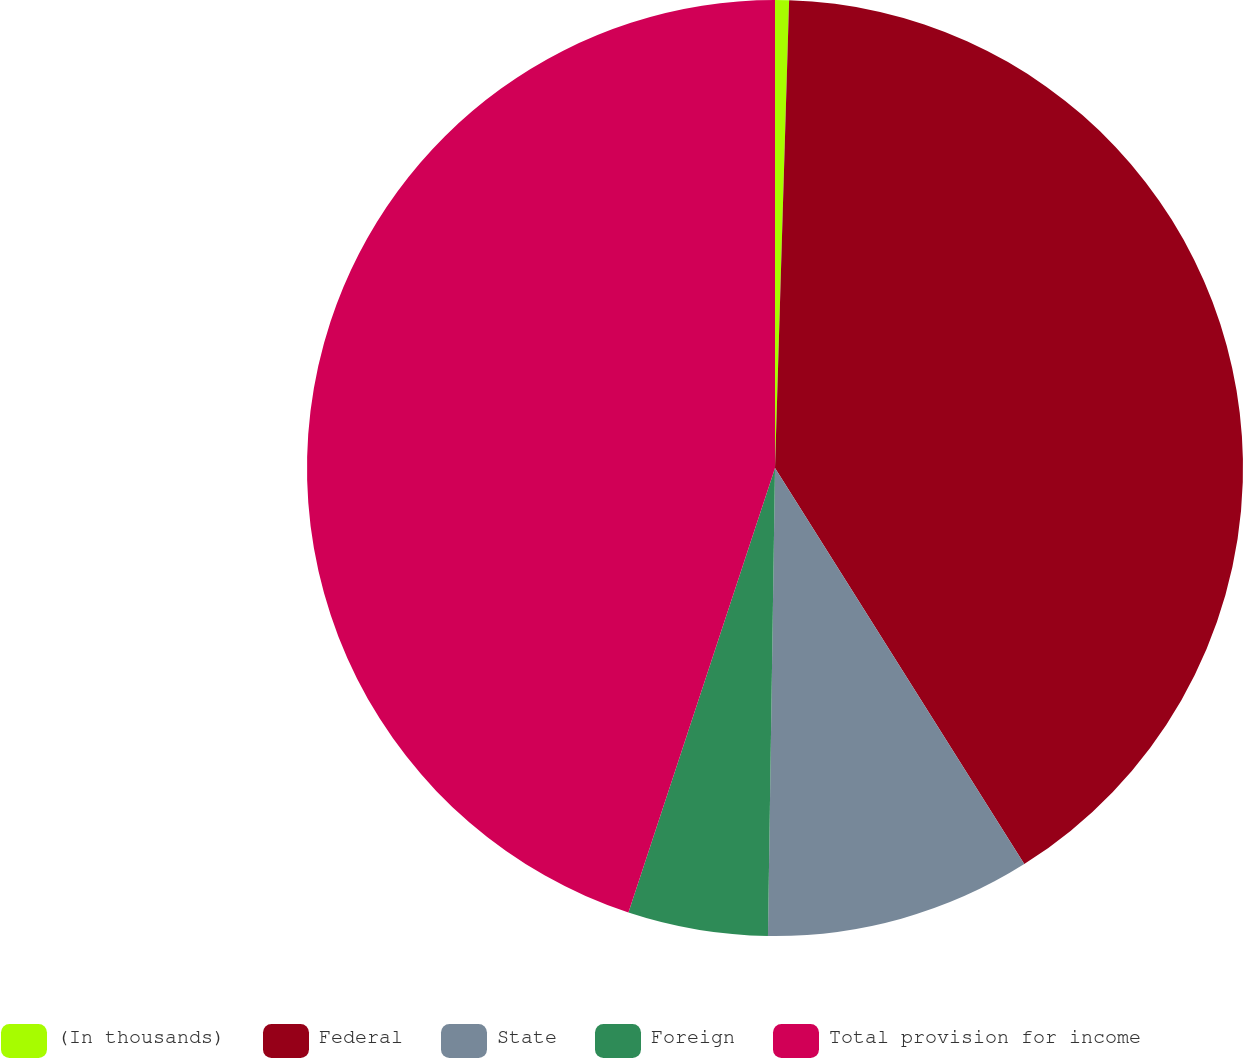Convert chart. <chart><loc_0><loc_0><loc_500><loc_500><pie_chart><fcel>(In thousands)<fcel>Federal<fcel>State<fcel>Foreign<fcel>Total provision for income<nl><fcel>0.48%<fcel>40.58%<fcel>9.18%<fcel>4.83%<fcel>44.93%<nl></chart> 